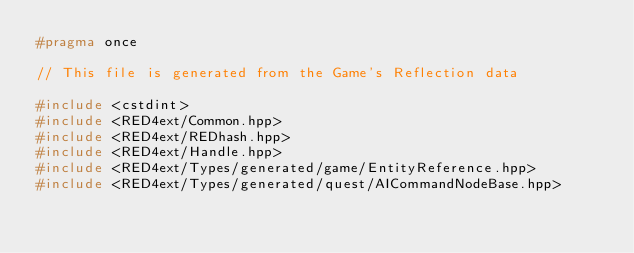Convert code to text. <code><loc_0><loc_0><loc_500><loc_500><_C++_>#pragma once

// This file is generated from the Game's Reflection data

#include <cstdint>
#include <RED4ext/Common.hpp>
#include <RED4ext/REDhash.hpp>
#include <RED4ext/Handle.hpp>
#include <RED4ext/Types/generated/game/EntityReference.hpp>
#include <RED4ext/Types/generated/quest/AICommandNodeBase.hpp>
</code> 